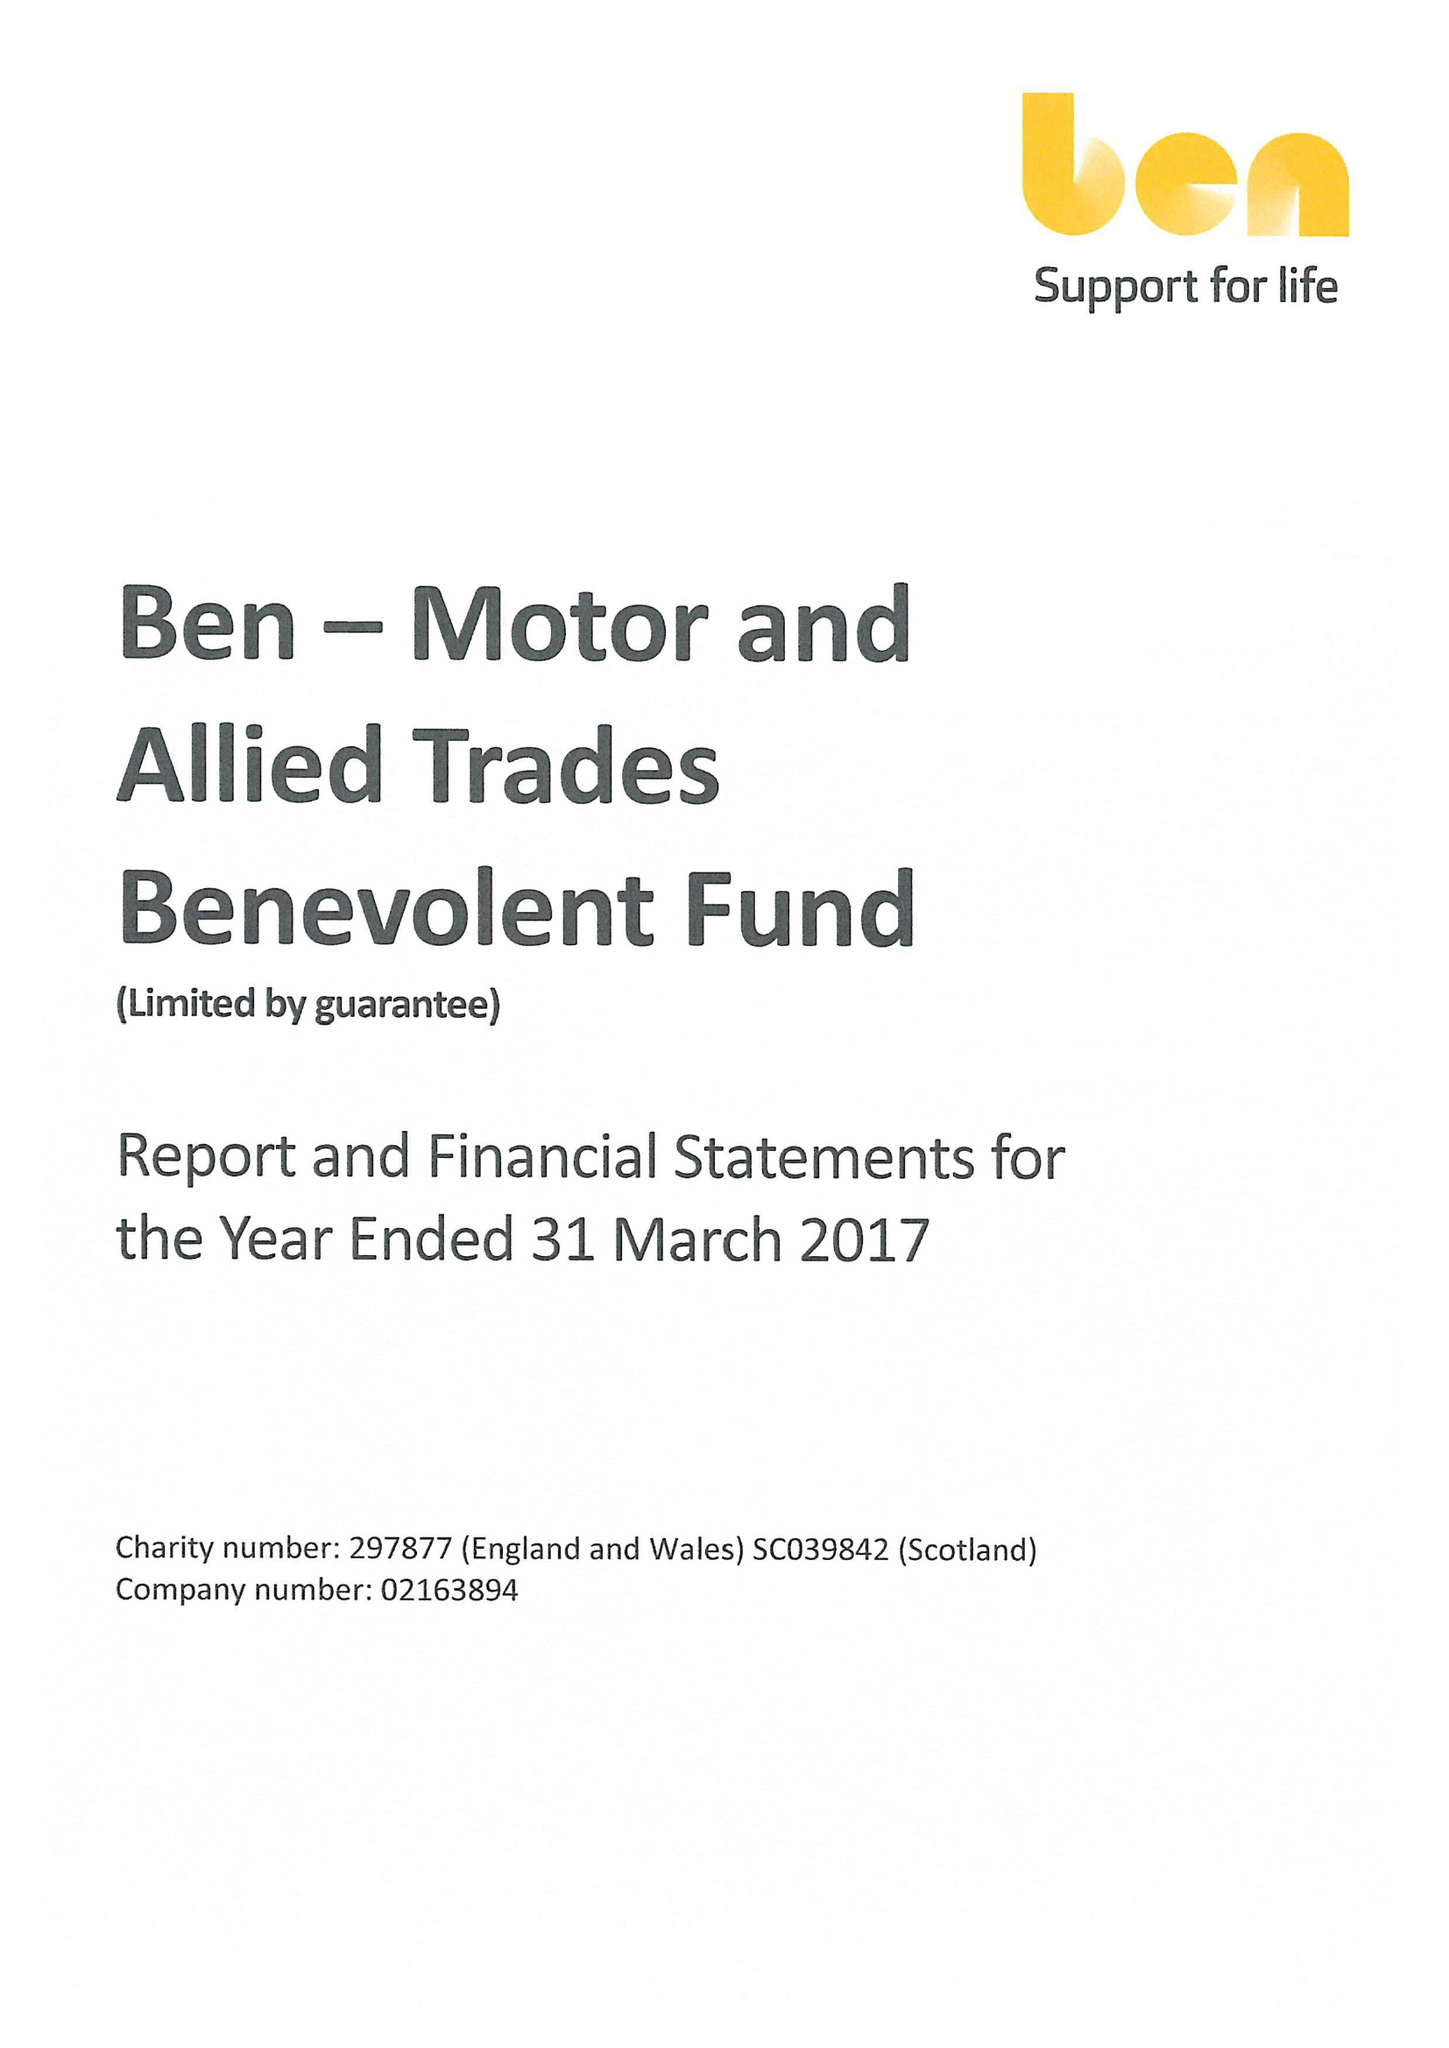What is the value for the address__post_town?
Answer the question using a single word or phrase. ASCOT 